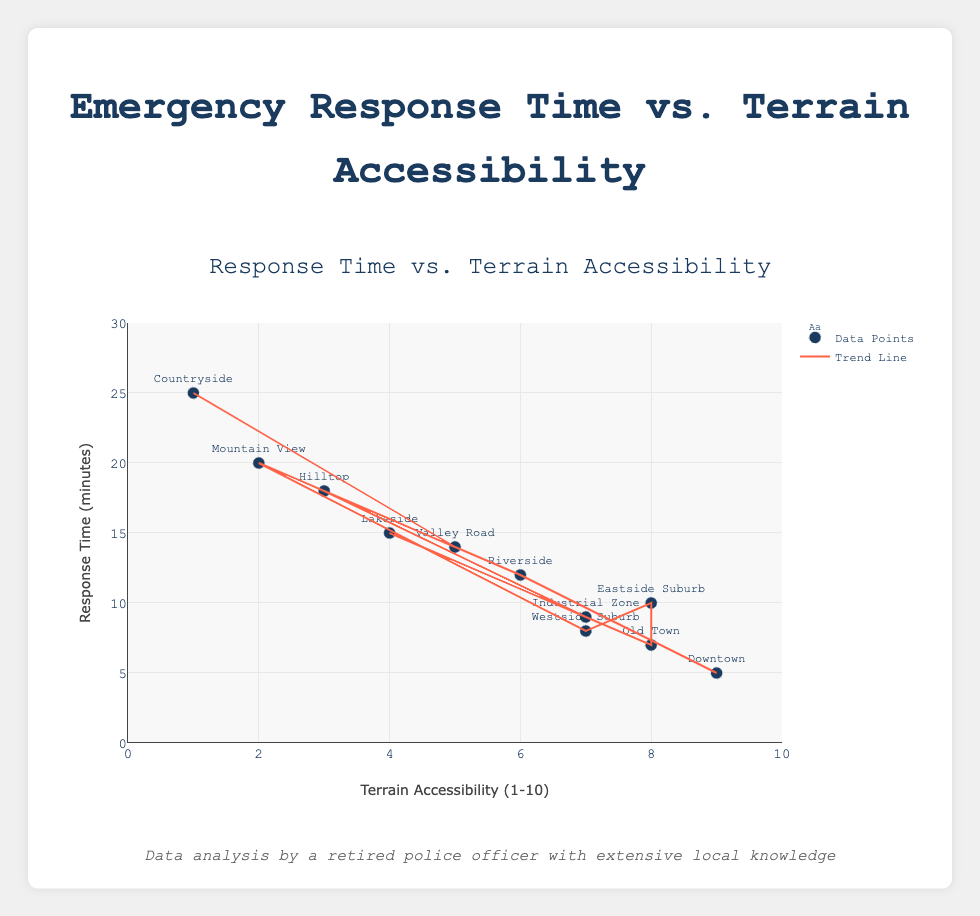What is the title of the plot? The title is displayed at the top of the plot, which gives an overview of what the plot represents. The title reads "Response Time vs. Terrain Accessibility" in enlarged, bold text at the top center of the chart.
Answer: Response Time vs. Terrain Accessibility How many data points are shown in the plot? By counting the number of markers, we can see each represents a data point. Each location corresponds to one data point, and there are 11 locations shown.
Answer: 11 Which location has the highest response time? By visually scanning the y-axis values for each data point's label, "Countryside" stands out at the topmost y-value, indicating the highest response time.
Answer: Countryside Is there a general trend between terrain accessibility and response time? The trend line on the scatter plot shows a clear negative slope, indicating that as terrain accessibility increases, the response time decreases. The trend line is a visual representation that helps to observe this relationship.
Answer: Negative correlation What is the terrain accessibility of “Mountain View”? By finding the label “Mountain View” on the plot and looking at its corresponding x-axis value, we see that the terrain accessibility is 2.
Answer: 2 How many locations have a response time greater than 15 minutes? We can identify data points above the 15-minute mark on the y-axis. These data points are "Countryside," "Mountain View," and "Hilltop," which totals to 3 locations.
Answer: 3 Which location has the highest terrain accessibility but not the lowest response time? After identifying the point at the maximum x-axis value (terrain accessibility of 9), "Downtown" is seen. By comparison, its response time (5 minutes) isn’t the lowest.
Answer: Downtown What is the average response time for locations with terrain accessibility of 7? First, identify the points with terrain accessibility of 7: "Westside Suburb" (8 minutes) and "Industrial Zone" (9 minutes). The average is (8 + 9) / 2 = 8.5 minutes.
Answer: 8.5 minutes What is the difference in response time between "Riverside" and "Hilltop"? By locating "Riverside" and "Hilltop" on the plot, we find their response times are 12 minutes and 18 minutes, respectively. The difference is 18 - 12 = 6 minutes.
Answer: 6 minutes How does the response time of "Lakeside" compare to that of "Riverside"? Finding both locations on the scatter plot, "Lakeside" has a response time of 15 minutes while "Riverside" has a response time of 12 minutes. Therefore, "Lakeside" has a higher response time.
Answer: Lakeside has a higher response time 